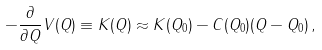<formula> <loc_0><loc_0><loc_500><loc_500>- \frac { \partial } { \partial Q } V ( Q ) \equiv K ( Q ) \approx K ( Q _ { 0 } ) - C ( Q _ { 0 } ) ( Q - Q _ { 0 } ) \, ,</formula> 